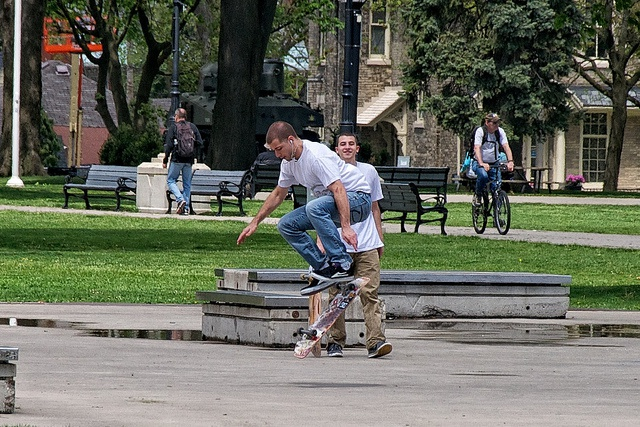Describe the objects in this image and their specific colors. I can see people in black, lavender, darkgray, and gray tones, people in black, gray, and lavender tones, people in black, gray, blue, and navy tones, bench in black, darkgray, and gray tones, and bench in black, gray, olive, and lightgreen tones in this image. 